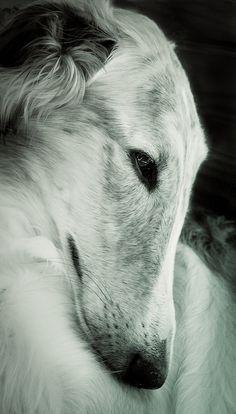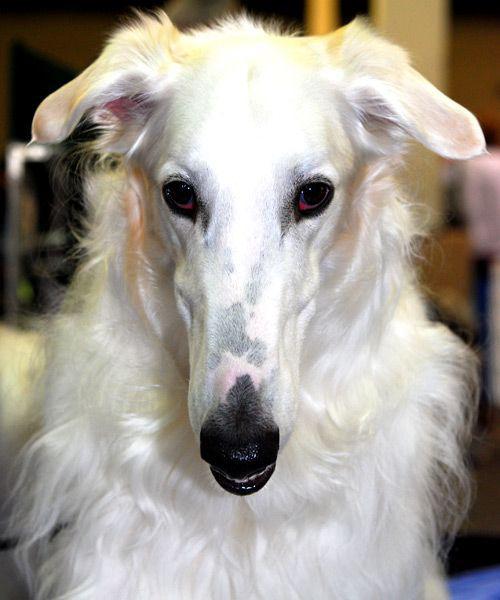The first image is the image on the left, the second image is the image on the right. Analyze the images presented: Is the assertion "Two white pointy nosed dogs are shown." valid? Answer yes or no. Yes. The first image is the image on the left, the second image is the image on the right. Examine the images to the left and right. Is the description "An image shows one hound standing still with its body in profile and tail hanging down." accurate? Answer yes or no. No. 